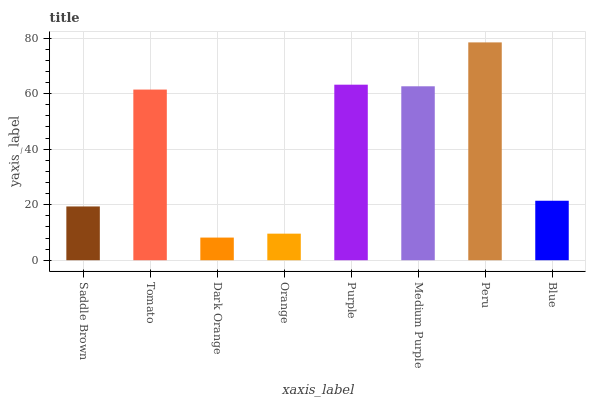Is Dark Orange the minimum?
Answer yes or no. Yes. Is Peru the maximum?
Answer yes or no. Yes. Is Tomato the minimum?
Answer yes or no. No. Is Tomato the maximum?
Answer yes or no. No. Is Tomato greater than Saddle Brown?
Answer yes or no. Yes. Is Saddle Brown less than Tomato?
Answer yes or no. Yes. Is Saddle Brown greater than Tomato?
Answer yes or no. No. Is Tomato less than Saddle Brown?
Answer yes or no. No. Is Tomato the high median?
Answer yes or no. Yes. Is Blue the low median?
Answer yes or no. Yes. Is Peru the high median?
Answer yes or no. No. Is Saddle Brown the low median?
Answer yes or no. No. 